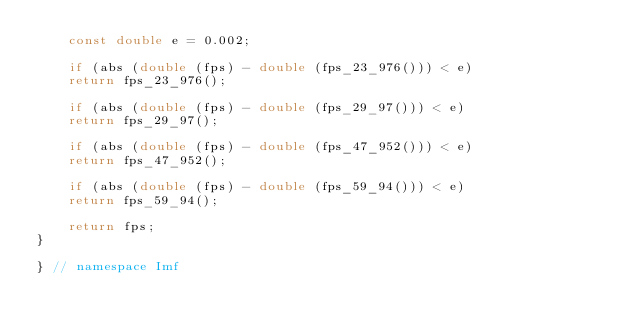Convert code to text. <code><loc_0><loc_0><loc_500><loc_500><_C++_>    const double e = 0.002;

    if (abs (double (fps) - double (fps_23_976())) < e)
    return fps_23_976();

    if (abs (double (fps) - double (fps_29_97())) < e)
    return fps_29_97();

    if (abs (double (fps) - double (fps_47_952())) < e)
    return fps_47_952();

    if (abs (double (fps) - double (fps_59_94())) < e)
    return fps_59_94();

    return fps;
}

} // namespace Imf
</code> 